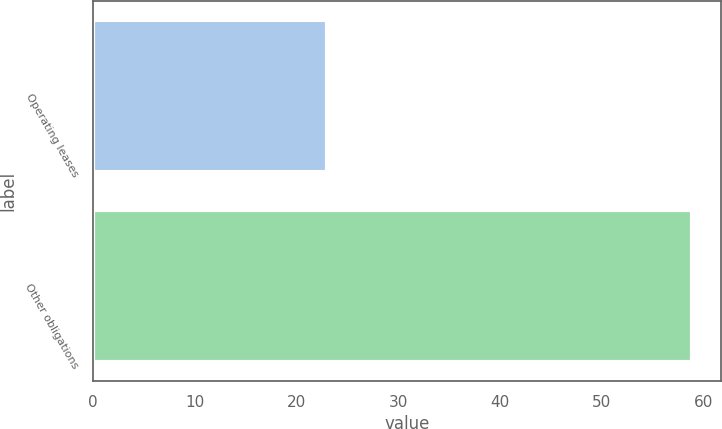<chart> <loc_0><loc_0><loc_500><loc_500><bar_chart><fcel>Operating leases<fcel>Other obligations<nl><fcel>23<fcel>58.8<nl></chart> 